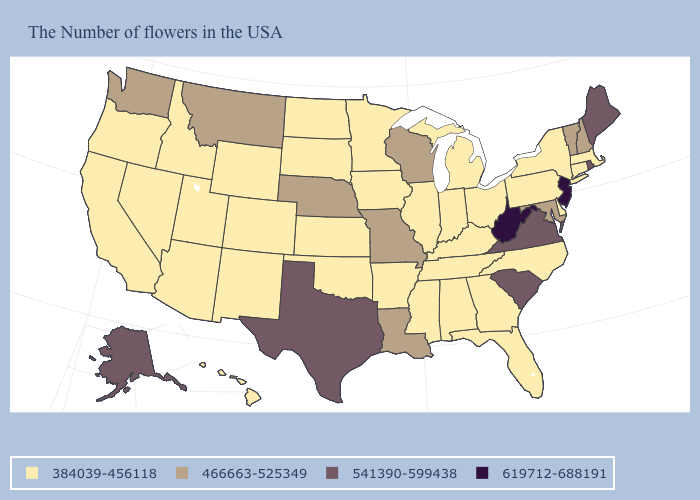Does Oregon have a lower value than New Hampshire?
Be succinct. Yes. What is the lowest value in the West?
Short answer required. 384039-456118. Name the states that have a value in the range 384039-456118?
Give a very brief answer. Massachusetts, Connecticut, New York, Delaware, Pennsylvania, North Carolina, Ohio, Florida, Georgia, Michigan, Kentucky, Indiana, Alabama, Tennessee, Illinois, Mississippi, Arkansas, Minnesota, Iowa, Kansas, Oklahoma, South Dakota, North Dakota, Wyoming, Colorado, New Mexico, Utah, Arizona, Idaho, Nevada, California, Oregon, Hawaii. What is the value of South Dakota?
Write a very short answer. 384039-456118. What is the highest value in the USA?
Give a very brief answer. 619712-688191. Among the states that border Pennsylvania , which have the lowest value?
Answer briefly. New York, Delaware, Ohio. Among the states that border Vermont , which have the highest value?
Write a very short answer. New Hampshire. Does North Carolina have a lower value than Texas?
Give a very brief answer. Yes. What is the value of Georgia?
Answer briefly. 384039-456118. Name the states that have a value in the range 541390-599438?
Quick response, please. Maine, Rhode Island, Virginia, South Carolina, Texas, Alaska. What is the value of Alabama?
Write a very short answer. 384039-456118. What is the value of Vermont?
Quick response, please. 466663-525349. Does the map have missing data?
Quick response, please. No. Does Montana have the lowest value in the West?
Answer briefly. No. Which states hav the highest value in the Northeast?
Keep it brief. New Jersey. 